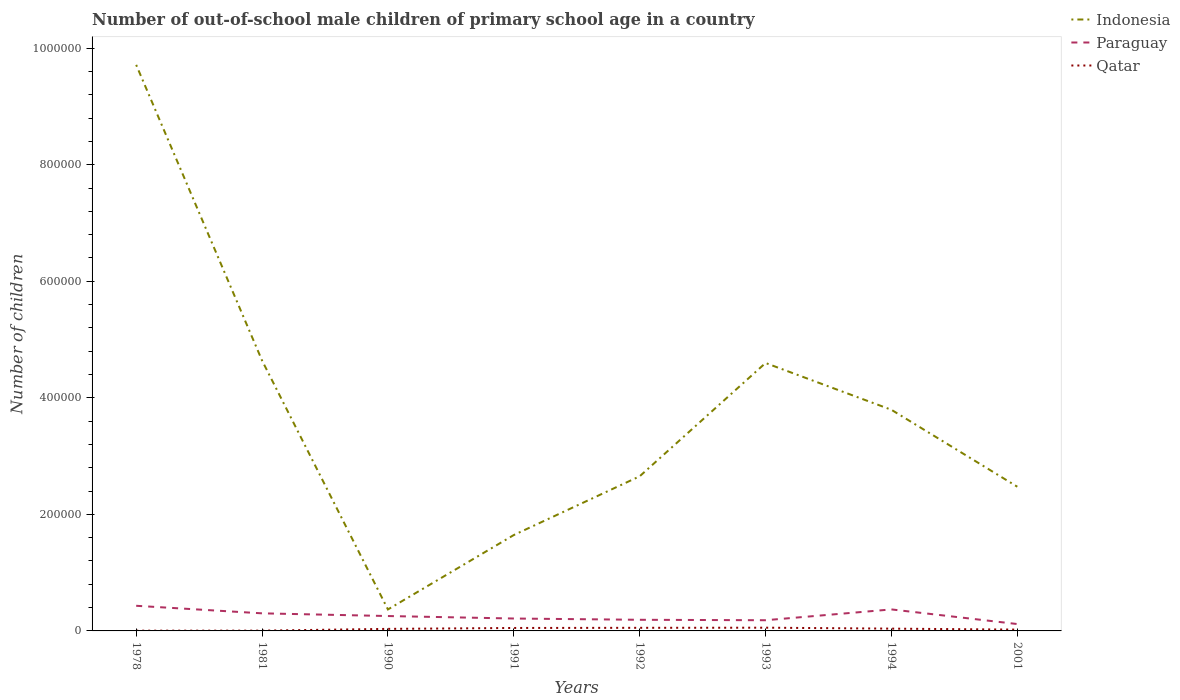Does the line corresponding to Qatar intersect with the line corresponding to Paraguay?
Give a very brief answer. No. Is the number of lines equal to the number of legend labels?
Offer a terse response. Yes. Across all years, what is the maximum number of out-of-school male children in Qatar?
Keep it short and to the point. 430. In which year was the number of out-of-school male children in Qatar maximum?
Give a very brief answer. 1978. What is the total number of out-of-school male children in Qatar in the graph?
Your answer should be compact. 1407. What is the difference between the highest and the second highest number of out-of-school male children in Indonesia?
Offer a terse response. 9.34e+05. How many years are there in the graph?
Keep it short and to the point. 8. What is the difference between two consecutive major ticks on the Y-axis?
Provide a succinct answer. 2.00e+05. Does the graph contain any zero values?
Give a very brief answer. No. Does the graph contain grids?
Ensure brevity in your answer.  No. What is the title of the graph?
Make the answer very short. Number of out-of-school male children of primary school age in a country. What is the label or title of the Y-axis?
Ensure brevity in your answer.  Number of children. What is the Number of children of Indonesia in 1978?
Your answer should be compact. 9.71e+05. What is the Number of children of Paraguay in 1978?
Offer a very short reply. 4.31e+04. What is the Number of children of Qatar in 1978?
Offer a very short reply. 430. What is the Number of children in Indonesia in 1981?
Provide a short and direct response. 4.64e+05. What is the Number of children of Paraguay in 1981?
Your response must be concise. 3.02e+04. What is the Number of children in Qatar in 1981?
Make the answer very short. 488. What is the Number of children in Indonesia in 1990?
Your answer should be very brief. 3.68e+04. What is the Number of children of Paraguay in 1990?
Offer a terse response. 2.56e+04. What is the Number of children in Qatar in 1990?
Offer a terse response. 3512. What is the Number of children in Indonesia in 1991?
Ensure brevity in your answer.  1.65e+05. What is the Number of children in Paraguay in 1991?
Offer a very short reply. 2.13e+04. What is the Number of children of Qatar in 1991?
Provide a short and direct response. 5064. What is the Number of children of Indonesia in 1992?
Offer a terse response. 2.65e+05. What is the Number of children of Paraguay in 1992?
Offer a very short reply. 1.91e+04. What is the Number of children of Qatar in 1992?
Offer a very short reply. 5330. What is the Number of children of Indonesia in 1993?
Offer a very short reply. 4.60e+05. What is the Number of children in Paraguay in 1993?
Offer a terse response. 1.84e+04. What is the Number of children of Qatar in 1993?
Provide a succinct answer. 5541. What is the Number of children in Indonesia in 1994?
Offer a very short reply. 3.79e+05. What is the Number of children in Paraguay in 1994?
Make the answer very short. 3.69e+04. What is the Number of children of Qatar in 1994?
Your answer should be compact. 3923. What is the Number of children of Indonesia in 2001?
Make the answer very short. 2.47e+05. What is the Number of children in Paraguay in 2001?
Your response must be concise. 1.18e+04. What is the Number of children of Qatar in 2001?
Make the answer very short. 2252. Across all years, what is the maximum Number of children in Indonesia?
Give a very brief answer. 9.71e+05. Across all years, what is the maximum Number of children of Paraguay?
Ensure brevity in your answer.  4.31e+04. Across all years, what is the maximum Number of children in Qatar?
Offer a very short reply. 5541. Across all years, what is the minimum Number of children in Indonesia?
Keep it short and to the point. 3.68e+04. Across all years, what is the minimum Number of children in Paraguay?
Give a very brief answer. 1.18e+04. Across all years, what is the minimum Number of children in Qatar?
Give a very brief answer. 430. What is the total Number of children of Indonesia in the graph?
Your response must be concise. 2.99e+06. What is the total Number of children in Paraguay in the graph?
Your answer should be compact. 2.06e+05. What is the total Number of children in Qatar in the graph?
Provide a short and direct response. 2.65e+04. What is the difference between the Number of children of Indonesia in 1978 and that in 1981?
Ensure brevity in your answer.  5.07e+05. What is the difference between the Number of children in Paraguay in 1978 and that in 1981?
Ensure brevity in your answer.  1.30e+04. What is the difference between the Number of children in Qatar in 1978 and that in 1981?
Keep it short and to the point. -58. What is the difference between the Number of children in Indonesia in 1978 and that in 1990?
Your answer should be very brief. 9.34e+05. What is the difference between the Number of children of Paraguay in 1978 and that in 1990?
Your answer should be compact. 1.76e+04. What is the difference between the Number of children in Qatar in 1978 and that in 1990?
Your answer should be very brief. -3082. What is the difference between the Number of children of Indonesia in 1978 and that in 1991?
Your answer should be very brief. 8.07e+05. What is the difference between the Number of children of Paraguay in 1978 and that in 1991?
Your answer should be compact. 2.19e+04. What is the difference between the Number of children of Qatar in 1978 and that in 1991?
Your answer should be compact. -4634. What is the difference between the Number of children in Indonesia in 1978 and that in 1992?
Offer a very short reply. 7.06e+05. What is the difference between the Number of children in Paraguay in 1978 and that in 1992?
Provide a succinct answer. 2.40e+04. What is the difference between the Number of children in Qatar in 1978 and that in 1992?
Keep it short and to the point. -4900. What is the difference between the Number of children of Indonesia in 1978 and that in 1993?
Provide a short and direct response. 5.12e+05. What is the difference between the Number of children of Paraguay in 1978 and that in 1993?
Offer a terse response. 2.48e+04. What is the difference between the Number of children in Qatar in 1978 and that in 1993?
Keep it short and to the point. -5111. What is the difference between the Number of children of Indonesia in 1978 and that in 1994?
Offer a terse response. 5.92e+05. What is the difference between the Number of children in Paraguay in 1978 and that in 1994?
Your response must be concise. 6243. What is the difference between the Number of children of Qatar in 1978 and that in 1994?
Provide a short and direct response. -3493. What is the difference between the Number of children in Indonesia in 1978 and that in 2001?
Provide a short and direct response. 7.24e+05. What is the difference between the Number of children in Paraguay in 1978 and that in 2001?
Your response must be concise. 3.13e+04. What is the difference between the Number of children in Qatar in 1978 and that in 2001?
Make the answer very short. -1822. What is the difference between the Number of children of Indonesia in 1981 and that in 1990?
Provide a succinct answer. 4.27e+05. What is the difference between the Number of children in Paraguay in 1981 and that in 1990?
Keep it short and to the point. 4638. What is the difference between the Number of children of Qatar in 1981 and that in 1990?
Your response must be concise. -3024. What is the difference between the Number of children of Indonesia in 1981 and that in 1991?
Offer a terse response. 2.99e+05. What is the difference between the Number of children in Paraguay in 1981 and that in 1991?
Your answer should be very brief. 8909. What is the difference between the Number of children of Qatar in 1981 and that in 1991?
Your response must be concise. -4576. What is the difference between the Number of children of Indonesia in 1981 and that in 1992?
Make the answer very short. 1.99e+05. What is the difference between the Number of children of Paraguay in 1981 and that in 1992?
Your response must be concise. 1.11e+04. What is the difference between the Number of children of Qatar in 1981 and that in 1992?
Ensure brevity in your answer.  -4842. What is the difference between the Number of children in Indonesia in 1981 and that in 1993?
Give a very brief answer. 4240. What is the difference between the Number of children in Paraguay in 1981 and that in 1993?
Ensure brevity in your answer.  1.18e+04. What is the difference between the Number of children in Qatar in 1981 and that in 1993?
Offer a very short reply. -5053. What is the difference between the Number of children in Indonesia in 1981 and that in 1994?
Ensure brevity in your answer.  8.46e+04. What is the difference between the Number of children in Paraguay in 1981 and that in 1994?
Offer a very short reply. -6714. What is the difference between the Number of children of Qatar in 1981 and that in 1994?
Offer a very short reply. -3435. What is the difference between the Number of children in Indonesia in 1981 and that in 2001?
Provide a succinct answer. 2.17e+05. What is the difference between the Number of children in Paraguay in 1981 and that in 2001?
Your answer should be compact. 1.84e+04. What is the difference between the Number of children of Qatar in 1981 and that in 2001?
Your answer should be compact. -1764. What is the difference between the Number of children of Indonesia in 1990 and that in 1991?
Ensure brevity in your answer.  -1.28e+05. What is the difference between the Number of children in Paraguay in 1990 and that in 1991?
Your response must be concise. 4271. What is the difference between the Number of children of Qatar in 1990 and that in 1991?
Ensure brevity in your answer.  -1552. What is the difference between the Number of children of Indonesia in 1990 and that in 1992?
Your answer should be very brief. -2.28e+05. What is the difference between the Number of children in Paraguay in 1990 and that in 1992?
Ensure brevity in your answer.  6445. What is the difference between the Number of children in Qatar in 1990 and that in 1992?
Offer a terse response. -1818. What is the difference between the Number of children in Indonesia in 1990 and that in 1993?
Make the answer very short. -4.23e+05. What is the difference between the Number of children of Paraguay in 1990 and that in 1993?
Give a very brief answer. 7200. What is the difference between the Number of children of Qatar in 1990 and that in 1993?
Provide a succinct answer. -2029. What is the difference between the Number of children of Indonesia in 1990 and that in 1994?
Your response must be concise. -3.43e+05. What is the difference between the Number of children in Paraguay in 1990 and that in 1994?
Offer a very short reply. -1.14e+04. What is the difference between the Number of children of Qatar in 1990 and that in 1994?
Provide a succinct answer. -411. What is the difference between the Number of children in Indonesia in 1990 and that in 2001?
Make the answer very short. -2.11e+05. What is the difference between the Number of children of Paraguay in 1990 and that in 2001?
Your response must be concise. 1.37e+04. What is the difference between the Number of children of Qatar in 1990 and that in 2001?
Offer a terse response. 1260. What is the difference between the Number of children in Indonesia in 1991 and that in 1992?
Keep it short and to the point. -1.01e+05. What is the difference between the Number of children in Paraguay in 1991 and that in 1992?
Your answer should be very brief. 2174. What is the difference between the Number of children of Qatar in 1991 and that in 1992?
Your answer should be compact. -266. What is the difference between the Number of children in Indonesia in 1991 and that in 1993?
Ensure brevity in your answer.  -2.95e+05. What is the difference between the Number of children of Paraguay in 1991 and that in 1993?
Your answer should be compact. 2929. What is the difference between the Number of children of Qatar in 1991 and that in 1993?
Make the answer very short. -477. What is the difference between the Number of children of Indonesia in 1991 and that in 1994?
Offer a very short reply. -2.15e+05. What is the difference between the Number of children of Paraguay in 1991 and that in 1994?
Provide a succinct answer. -1.56e+04. What is the difference between the Number of children of Qatar in 1991 and that in 1994?
Your answer should be compact. 1141. What is the difference between the Number of children of Indonesia in 1991 and that in 2001?
Provide a succinct answer. -8.29e+04. What is the difference between the Number of children of Paraguay in 1991 and that in 2001?
Provide a succinct answer. 9477. What is the difference between the Number of children in Qatar in 1991 and that in 2001?
Ensure brevity in your answer.  2812. What is the difference between the Number of children of Indonesia in 1992 and that in 1993?
Offer a very short reply. -1.94e+05. What is the difference between the Number of children of Paraguay in 1992 and that in 1993?
Provide a succinct answer. 755. What is the difference between the Number of children of Qatar in 1992 and that in 1993?
Offer a very short reply. -211. What is the difference between the Number of children in Indonesia in 1992 and that in 1994?
Your answer should be compact. -1.14e+05. What is the difference between the Number of children of Paraguay in 1992 and that in 1994?
Give a very brief answer. -1.78e+04. What is the difference between the Number of children of Qatar in 1992 and that in 1994?
Offer a terse response. 1407. What is the difference between the Number of children of Indonesia in 1992 and that in 2001?
Keep it short and to the point. 1.79e+04. What is the difference between the Number of children of Paraguay in 1992 and that in 2001?
Your response must be concise. 7303. What is the difference between the Number of children of Qatar in 1992 and that in 2001?
Your answer should be very brief. 3078. What is the difference between the Number of children in Indonesia in 1993 and that in 1994?
Your response must be concise. 8.03e+04. What is the difference between the Number of children of Paraguay in 1993 and that in 1994?
Your answer should be very brief. -1.86e+04. What is the difference between the Number of children in Qatar in 1993 and that in 1994?
Your response must be concise. 1618. What is the difference between the Number of children of Indonesia in 1993 and that in 2001?
Your response must be concise. 2.12e+05. What is the difference between the Number of children in Paraguay in 1993 and that in 2001?
Your answer should be very brief. 6548. What is the difference between the Number of children in Qatar in 1993 and that in 2001?
Your answer should be very brief. 3289. What is the difference between the Number of children of Indonesia in 1994 and that in 2001?
Offer a terse response. 1.32e+05. What is the difference between the Number of children of Paraguay in 1994 and that in 2001?
Give a very brief answer. 2.51e+04. What is the difference between the Number of children of Qatar in 1994 and that in 2001?
Your answer should be very brief. 1671. What is the difference between the Number of children in Indonesia in 1978 and the Number of children in Paraguay in 1981?
Your answer should be compact. 9.41e+05. What is the difference between the Number of children of Indonesia in 1978 and the Number of children of Qatar in 1981?
Your answer should be very brief. 9.71e+05. What is the difference between the Number of children of Paraguay in 1978 and the Number of children of Qatar in 1981?
Provide a short and direct response. 4.27e+04. What is the difference between the Number of children in Indonesia in 1978 and the Number of children in Paraguay in 1990?
Ensure brevity in your answer.  9.46e+05. What is the difference between the Number of children in Indonesia in 1978 and the Number of children in Qatar in 1990?
Make the answer very short. 9.68e+05. What is the difference between the Number of children of Paraguay in 1978 and the Number of children of Qatar in 1990?
Your answer should be very brief. 3.96e+04. What is the difference between the Number of children of Indonesia in 1978 and the Number of children of Paraguay in 1991?
Provide a succinct answer. 9.50e+05. What is the difference between the Number of children of Indonesia in 1978 and the Number of children of Qatar in 1991?
Offer a terse response. 9.66e+05. What is the difference between the Number of children of Paraguay in 1978 and the Number of children of Qatar in 1991?
Provide a short and direct response. 3.81e+04. What is the difference between the Number of children in Indonesia in 1978 and the Number of children in Paraguay in 1992?
Make the answer very short. 9.52e+05. What is the difference between the Number of children of Indonesia in 1978 and the Number of children of Qatar in 1992?
Make the answer very short. 9.66e+05. What is the difference between the Number of children in Paraguay in 1978 and the Number of children in Qatar in 1992?
Your answer should be very brief. 3.78e+04. What is the difference between the Number of children of Indonesia in 1978 and the Number of children of Paraguay in 1993?
Provide a short and direct response. 9.53e+05. What is the difference between the Number of children in Indonesia in 1978 and the Number of children in Qatar in 1993?
Provide a succinct answer. 9.66e+05. What is the difference between the Number of children of Paraguay in 1978 and the Number of children of Qatar in 1993?
Keep it short and to the point. 3.76e+04. What is the difference between the Number of children in Indonesia in 1978 and the Number of children in Paraguay in 1994?
Give a very brief answer. 9.34e+05. What is the difference between the Number of children in Indonesia in 1978 and the Number of children in Qatar in 1994?
Give a very brief answer. 9.67e+05. What is the difference between the Number of children of Paraguay in 1978 and the Number of children of Qatar in 1994?
Make the answer very short. 3.92e+04. What is the difference between the Number of children of Indonesia in 1978 and the Number of children of Paraguay in 2001?
Give a very brief answer. 9.60e+05. What is the difference between the Number of children in Indonesia in 1978 and the Number of children in Qatar in 2001?
Keep it short and to the point. 9.69e+05. What is the difference between the Number of children of Paraguay in 1978 and the Number of children of Qatar in 2001?
Your answer should be compact. 4.09e+04. What is the difference between the Number of children in Indonesia in 1981 and the Number of children in Paraguay in 1990?
Ensure brevity in your answer.  4.38e+05. What is the difference between the Number of children of Indonesia in 1981 and the Number of children of Qatar in 1990?
Your answer should be compact. 4.60e+05. What is the difference between the Number of children in Paraguay in 1981 and the Number of children in Qatar in 1990?
Your answer should be very brief. 2.67e+04. What is the difference between the Number of children in Indonesia in 1981 and the Number of children in Paraguay in 1991?
Provide a short and direct response. 4.43e+05. What is the difference between the Number of children in Indonesia in 1981 and the Number of children in Qatar in 1991?
Your answer should be very brief. 4.59e+05. What is the difference between the Number of children of Paraguay in 1981 and the Number of children of Qatar in 1991?
Offer a terse response. 2.51e+04. What is the difference between the Number of children of Indonesia in 1981 and the Number of children of Paraguay in 1992?
Your response must be concise. 4.45e+05. What is the difference between the Number of children of Indonesia in 1981 and the Number of children of Qatar in 1992?
Provide a short and direct response. 4.59e+05. What is the difference between the Number of children in Paraguay in 1981 and the Number of children in Qatar in 1992?
Offer a very short reply. 2.49e+04. What is the difference between the Number of children of Indonesia in 1981 and the Number of children of Paraguay in 1993?
Give a very brief answer. 4.46e+05. What is the difference between the Number of children in Indonesia in 1981 and the Number of children in Qatar in 1993?
Offer a very short reply. 4.58e+05. What is the difference between the Number of children of Paraguay in 1981 and the Number of children of Qatar in 1993?
Provide a short and direct response. 2.46e+04. What is the difference between the Number of children of Indonesia in 1981 and the Number of children of Paraguay in 1994?
Provide a succinct answer. 4.27e+05. What is the difference between the Number of children in Indonesia in 1981 and the Number of children in Qatar in 1994?
Your answer should be compact. 4.60e+05. What is the difference between the Number of children in Paraguay in 1981 and the Number of children in Qatar in 1994?
Give a very brief answer. 2.63e+04. What is the difference between the Number of children in Indonesia in 1981 and the Number of children in Paraguay in 2001?
Offer a terse response. 4.52e+05. What is the difference between the Number of children in Indonesia in 1981 and the Number of children in Qatar in 2001?
Offer a terse response. 4.62e+05. What is the difference between the Number of children of Paraguay in 1981 and the Number of children of Qatar in 2001?
Make the answer very short. 2.79e+04. What is the difference between the Number of children of Indonesia in 1990 and the Number of children of Paraguay in 1991?
Offer a very short reply. 1.56e+04. What is the difference between the Number of children of Indonesia in 1990 and the Number of children of Qatar in 1991?
Ensure brevity in your answer.  3.18e+04. What is the difference between the Number of children in Paraguay in 1990 and the Number of children in Qatar in 1991?
Offer a very short reply. 2.05e+04. What is the difference between the Number of children in Indonesia in 1990 and the Number of children in Paraguay in 1992?
Ensure brevity in your answer.  1.77e+04. What is the difference between the Number of children in Indonesia in 1990 and the Number of children in Qatar in 1992?
Your answer should be compact. 3.15e+04. What is the difference between the Number of children in Paraguay in 1990 and the Number of children in Qatar in 1992?
Keep it short and to the point. 2.02e+04. What is the difference between the Number of children of Indonesia in 1990 and the Number of children of Paraguay in 1993?
Your answer should be very brief. 1.85e+04. What is the difference between the Number of children in Indonesia in 1990 and the Number of children in Qatar in 1993?
Provide a succinct answer. 3.13e+04. What is the difference between the Number of children in Paraguay in 1990 and the Number of children in Qatar in 1993?
Offer a terse response. 2.00e+04. What is the difference between the Number of children in Indonesia in 1990 and the Number of children in Paraguay in 1994?
Your answer should be compact. -53. What is the difference between the Number of children of Indonesia in 1990 and the Number of children of Qatar in 1994?
Ensure brevity in your answer.  3.29e+04. What is the difference between the Number of children in Paraguay in 1990 and the Number of children in Qatar in 1994?
Your response must be concise. 2.16e+04. What is the difference between the Number of children of Indonesia in 1990 and the Number of children of Paraguay in 2001?
Your answer should be very brief. 2.50e+04. What is the difference between the Number of children of Indonesia in 1990 and the Number of children of Qatar in 2001?
Your answer should be very brief. 3.46e+04. What is the difference between the Number of children in Paraguay in 1990 and the Number of children in Qatar in 2001?
Provide a succinct answer. 2.33e+04. What is the difference between the Number of children in Indonesia in 1991 and the Number of children in Paraguay in 1992?
Your answer should be very brief. 1.45e+05. What is the difference between the Number of children of Indonesia in 1991 and the Number of children of Qatar in 1992?
Ensure brevity in your answer.  1.59e+05. What is the difference between the Number of children in Paraguay in 1991 and the Number of children in Qatar in 1992?
Provide a succinct answer. 1.60e+04. What is the difference between the Number of children in Indonesia in 1991 and the Number of children in Paraguay in 1993?
Make the answer very short. 1.46e+05. What is the difference between the Number of children of Indonesia in 1991 and the Number of children of Qatar in 1993?
Your response must be concise. 1.59e+05. What is the difference between the Number of children of Paraguay in 1991 and the Number of children of Qatar in 1993?
Provide a succinct answer. 1.57e+04. What is the difference between the Number of children of Indonesia in 1991 and the Number of children of Paraguay in 1994?
Offer a terse response. 1.28e+05. What is the difference between the Number of children in Indonesia in 1991 and the Number of children in Qatar in 1994?
Ensure brevity in your answer.  1.61e+05. What is the difference between the Number of children of Paraguay in 1991 and the Number of children of Qatar in 1994?
Offer a very short reply. 1.74e+04. What is the difference between the Number of children of Indonesia in 1991 and the Number of children of Paraguay in 2001?
Make the answer very short. 1.53e+05. What is the difference between the Number of children of Indonesia in 1991 and the Number of children of Qatar in 2001?
Provide a succinct answer. 1.62e+05. What is the difference between the Number of children of Paraguay in 1991 and the Number of children of Qatar in 2001?
Ensure brevity in your answer.  1.90e+04. What is the difference between the Number of children of Indonesia in 1992 and the Number of children of Paraguay in 1993?
Provide a short and direct response. 2.47e+05. What is the difference between the Number of children of Indonesia in 1992 and the Number of children of Qatar in 1993?
Provide a short and direct response. 2.60e+05. What is the difference between the Number of children in Paraguay in 1992 and the Number of children in Qatar in 1993?
Your answer should be compact. 1.36e+04. What is the difference between the Number of children in Indonesia in 1992 and the Number of children in Paraguay in 1994?
Your response must be concise. 2.28e+05. What is the difference between the Number of children in Indonesia in 1992 and the Number of children in Qatar in 1994?
Offer a very short reply. 2.61e+05. What is the difference between the Number of children in Paraguay in 1992 and the Number of children in Qatar in 1994?
Make the answer very short. 1.52e+04. What is the difference between the Number of children of Indonesia in 1992 and the Number of children of Paraguay in 2001?
Offer a very short reply. 2.54e+05. What is the difference between the Number of children in Indonesia in 1992 and the Number of children in Qatar in 2001?
Ensure brevity in your answer.  2.63e+05. What is the difference between the Number of children in Paraguay in 1992 and the Number of children in Qatar in 2001?
Make the answer very short. 1.69e+04. What is the difference between the Number of children of Indonesia in 1993 and the Number of children of Paraguay in 1994?
Make the answer very short. 4.23e+05. What is the difference between the Number of children of Indonesia in 1993 and the Number of children of Qatar in 1994?
Keep it short and to the point. 4.56e+05. What is the difference between the Number of children in Paraguay in 1993 and the Number of children in Qatar in 1994?
Your answer should be compact. 1.44e+04. What is the difference between the Number of children in Indonesia in 1993 and the Number of children in Paraguay in 2001?
Give a very brief answer. 4.48e+05. What is the difference between the Number of children of Indonesia in 1993 and the Number of children of Qatar in 2001?
Provide a short and direct response. 4.58e+05. What is the difference between the Number of children in Paraguay in 1993 and the Number of children in Qatar in 2001?
Your answer should be very brief. 1.61e+04. What is the difference between the Number of children of Indonesia in 1994 and the Number of children of Paraguay in 2001?
Your answer should be very brief. 3.68e+05. What is the difference between the Number of children of Indonesia in 1994 and the Number of children of Qatar in 2001?
Ensure brevity in your answer.  3.77e+05. What is the difference between the Number of children in Paraguay in 1994 and the Number of children in Qatar in 2001?
Make the answer very short. 3.47e+04. What is the average Number of children of Indonesia per year?
Keep it short and to the point. 3.74e+05. What is the average Number of children of Paraguay per year?
Offer a very short reply. 2.58e+04. What is the average Number of children in Qatar per year?
Offer a terse response. 3317.5. In the year 1978, what is the difference between the Number of children in Indonesia and Number of children in Paraguay?
Ensure brevity in your answer.  9.28e+05. In the year 1978, what is the difference between the Number of children of Indonesia and Number of children of Qatar?
Offer a terse response. 9.71e+05. In the year 1978, what is the difference between the Number of children of Paraguay and Number of children of Qatar?
Your answer should be compact. 4.27e+04. In the year 1981, what is the difference between the Number of children in Indonesia and Number of children in Paraguay?
Ensure brevity in your answer.  4.34e+05. In the year 1981, what is the difference between the Number of children of Indonesia and Number of children of Qatar?
Provide a succinct answer. 4.64e+05. In the year 1981, what is the difference between the Number of children of Paraguay and Number of children of Qatar?
Offer a very short reply. 2.97e+04. In the year 1990, what is the difference between the Number of children in Indonesia and Number of children in Paraguay?
Provide a succinct answer. 1.13e+04. In the year 1990, what is the difference between the Number of children in Indonesia and Number of children in Qatar?
Your response must be concise. 3.33e+04. In the year 1990, what is the difference between the Number of children of Paraguay and Number of children of Qatar?
Make the answer very short. 2.20e+04. In the year 1991, what is the difference between the Number of children of Indonesia and Number of children of Paraguay?
Offer a very short reply. 1.43e+05. In the year 1991, what is the difference between the Number of children in Indonesia and Number of children in Qatar?
Provide a short and direct response. 1.59e+05. In the year 1991, what is the difference between the Number of children of Paraguay and Number of children of Qatar?
Give a very brief answer. 1.62e+04. In the year 1992, what is the difference between the Number of children of Indonesia and Number of children of Paraguay?
Offer a terse response. 2.46e+05. In the year 1992, what is the difference between the Number of children in Indonesia and Number of children in Qatar?
Provide a short and direct response. 2.60e+05. In the year 1992, what is the difference between the Number of children in Paraguay and Number of children in Qatar?
Offer a very short reply. 1.38e+04. In the year 1993, what is the difference between the Number of children in Indonesia and Number of children in Paraguay?
Provide a short and direct response. 4.41e+05. In the year 1993, what is the difference between the Number of children in Indonesia and Number of children in Qatar?
Offer a terse response. 4.54e+05. In the year 1993, what is the difference between the Number of children in Paraguay and Number of children in Qatar?
Provide a succinct answer. 1.28e+04. In the year 1994, what is the difference between the Number of children of Indonesia and Number of children of Paraguay?
Provide a succinct answer. 3.43e+05. In the year 1994, what is the difference between the Number of children of Indonesia and Number of children of Qatar?
Provide a succinct answer. 3.76e+05. In the year 1994, what is the difference between the Number of children in Paraguay and Number of children in Qatar?
Offer a very short reply. 3.30e+04. In the year 2001, what is the difference between the Number of children in Indonesia and Number of children in Paraguay?
Offer a terse response. 2.36e+05. In the year 2001, what is the difference between the Number of children of Indonesia and Number of children of Qatar?
Your response must be concise. 2.45e+05. In the year 2001, what is the difference between the Number of children in Paraguay and Number of children in Qatar?
Make the answer very short. 9551. What is the ratio of the Number of children in Indonesia in 1978 to that in 1981?
Offer a terse response. 2.09. What is the ratio of the Number of children in Paraguay in 1978 to that in 1981?
Ensure brevity in your answer.  1.43. What is the ratio of the Number of children in Qatar in 1978 to that in 1981?
Your response must be concise. 0.88. What is the ratio of the Number of children of Indonesia in 1978 to that in 1990?
Your response must be concise. 26.36. What is the ratio of the Number of children in Paraguay in 1978 to that in 1990?
Provide a short and direct response. 1.69. What is the ratio of the Number of children of Qatar in 1978 to that in 1990?
Ensure brevity in your answer.  0.12. What is the ratio of the Number of children in Indonesia in 1978 to that in 1991?
Keep it short and to the point. 5.9. What is the ratio of the Number of children in Paraguay in 1978 to that in 1991?
Offer a terse response. 2.03. What is the ratio of the Number of children of Qatar in 1978 to that in 1991?
Provide a short and direct response. 0.08. What is the ratio of the Number of children of Indonesia in 1978 to that in 1992?
Your response must be concise. 3.66. What is the ratio of the Number of children in Paraguay in 1978 to that in 1992?
Your answer should be very brief. 2.26. What is the ratio of the Number of children in Qatar in 1978 to that in 1992?
Offer a very short reply. 0.08. What is the ratio of the Number of children of Indonesia in 1978 to that in 1993?
Provide a succinct answer. 2.11. What is the ratio of the Number of children of Paraguay in 1978 to that in 1993?
Offer a very short reply. 2.35. What is the ratio of the Number of children of Qatar in 1978 to that in 1993?
Keep it short and to the point. 0.08. What is the ratio of the Number of children of Indonesia in 1978 to that in 1994?
Your answer should be compact. 2.56. What is the ratio of the Number of children in Paraguay in 1978 to that in 1994?
Provide a short and direct response. 1.17. What is the ratio of the Number of children of Qatar in 1978 to that in 1994?
Your response must be concise. 0.11. What is the ratio of the Number of children of Indonesia in 1978 to that in 2001?
Offer a very short reply. 3.93. What is the ratio of the Number of children in Paraguay in 1978 to that in 2001?
Offer a very short reply. 3.66. What is the ratio of the Number of children in Qatar in 1978 to that in 2001?
Offer a terse response. 0.19. What is the ratio of the Number of children in Indonesia in 1981 to that in 1990?
Your response must be concise. 12.59. What is the ratio of the Number of children in Paraguay in 1981 to that in 1990?
Provide a succinct answer. 1.18. What is the ratio of the Number of children in Qatar in 1981 to that in 1990?
Give a very brief answer. 0.14. What is the ratio of the Number of children in Indonesia in 1981 to that in 1991?
Provide a succinct answer. 2.82. What is the ratio of the Number of children of Paraguay in 1981 to that in 1991?
Give a very brief answer. 1.42. What is the ratio of the Number of children of Qatar in 1981 to that in 1991?
Your response must be concise. 0.1. What is the ratio of the Number of children of Indonesia in 1981 to that in 1992?
Ensure brevity in your answer.  1.75. What is the ratio of the Number of children of Paraguay in 1981 to that in 1992?
Offer a terse response. 1.58. What is the ratio of the Number of children of Qatar in 1981 to that in 1992?
Provide a succinct answer. 0.09. What is the ratio of the Number of children in Indonesia in 1981 to that in 1993?
Give a very brief answer. 1.01. What is the ratio of the Number of children of Paraguay in 1981 to that in 1993?
Offer a terse response. 1.65. What is the ratio of the Number of children of Qatar in 1981 to that in 1993?
Ensure brevity in your answer.  0.09. What is the ratio of the Number of children of Indonesia in 1981 to that in 1994?
Give a very brief answer. 1.22. What is the ratio of the Number of children in Paraguay in 1981 to that in 1994?
Your answer should be compact. 0.82. What is the ratio of the Number of children of Qatar in 1981 to that in 1994?
Keep it short and to the point. 0.12. What is the ratio of the Number of children of Indonesia in 1981 to that in 2001?
Give a very brief answer. 1.88. What is the ratio of the Number of children in Paraguay in 1981 to that in 2001?
Keep it short and to the point. 2.56. What is the ratio of the Number of children of Qatar in 1981 to that in 2001?
Your answer should be compact. 0.22. What is the ratio of the Number of children of Indonesia in 1990 to that in 1991?
Keep it short and to the point. 0.22. What is the ratio of the Number of children in Paraguay in 1990 to that in 1991?
Provide a short and direct response. 1.2. What is the ratio of the Number of children in Qatar in 1990 to that in 1991?
Provide a succinct answer. 0.69. What is the ratio of the Number of children of Indonesia in 1990 to that in 1992?
Provide a short and direct response. 0.14. What is the ratio of the Number of children of Paraguay in 1990 to that in 1992?
Your response must be concise. 1.34. What is the ratio of the Number of children in Qatar in 1990 to that in 1992?
Give a very brief answer. 0.66. What is the ratio of the Number of children in Indonesia in 1990 to that in 1993?
Ensure brevity in your answer.  0.08. What is the ratio of the Number of children of Paraguay in 1990 to that in 1993?
Offer a very short reply. 1.39. What is the ratio of the Number of children of Qatar in 1990 to that in 1993?
Offer a very short reply. 0.63. What is the ratio of the Number of children in Indonesia in 1990 to that in 1994?
Your answer should be very brief. 0.1. What is the ratio of the Number of children of Paraguay in 1990 to that in 1994?
Ensure brevity in your answer.  0.69. What is the ratio of the Number of children of Qatar in 1990 to that in 1994?
Provide a short and direct response. 0.9. What is the ratio of the Number of children of Indonesia in 1990 to that in 2001?
Make the answer very short. 0.15. What is the ratio of the Number of children of Paraguay in 1990 to that in 2001?
Your answer should be compact. 2.16. What is the ratio of the Number of children in Qatar in 1990 to that in 2001?
Your answer should be very brief. 1.56. What is the ratio of the Number of children of Indonesia in 1991 to that in 1992?
Offer a terse response. 0.62. What is the ratio of the Number of children of Paraguay in 1991 to that in 1992?
Your response must be concise. 1.11. What is the ratio of the Number of children of Qatar in 1991 to that in 1992?
Offer a terse response. 0.95. What is the ratio of the Number of children of Indonesia in 1991 to that in 1993?
Offer a terse response. 0.36. What is the ratio of the Number of children in Paraguay in 1991 to that in 1993?
Provide a short and direct response. 1.16. What is the ratio of the Number of children of Qatar in 1991 to that in 1993?
Your response must be concise. 0.91. What is the ratio of the Number of children in Indonesia in 1991 to that in 1994?
Give a very brief answer. 0.43. What is the ratio of the Number of children in Paraguay in 1991 to that in 1994?
Keep it short and to the point. 0.58. What is the ratio of the Number of children in Qatar in 1991 to that in 1994?
Ensure brevity in your answer.  1.29. What is the ratio of the Number of children in Indonesia in 1991 to that in 2001?
Ensure brevity in your answer.  0.67. What is the ratio of the Number of children in Paraguay in 1991 to that in 2001?
Offer a very short reply. 1.8. What is the ratio of the Number of children in Qatar in 1991 to that in 2001?
Provide a succinct answer. 2.25. What is the ratio of the Number of children in Indonesia in 1992 to that in 1993?
Your answer should be compact. 0.58. What is the ratio of the Number of children of Paraguay in 1992 to that in 1993?
Your response must be concise. 1.04. What is the ratio of the Number of children in Qatar in 1992 to that in 1993?
Offer a terse response. 0.96. What is the ratio of the Number of children in Indonesia in 1992 to that in 1994?
Offer a very short reply. 0.7. What is the ratio of the Number of children in Paraguay in 1992 to that in 1994?
Provide a succinct answer. 0.52. What is the ratio of the Number of children in Qatar in 1992 to that in 1994?
Provide a succinct answer. 1.36. What is the ratio of the Number of children in Indonesia in 1992 to that in 2001?
Provide a short and direct response. 1.07. What is the ratio of the Number of children of Paraguay in 1992 to that in 2001?
Offer a terse response. 1.62. What is the ratio of the Number of children in Qatar in 1992 to that in 2001?
Ensure brevity in your answer.  2.37. What is the ratio of the Number of children in Indonesia in 1993 to that in 1994?
Offer a terse response. 1.21. What is the ratio of the Number of children of Paraguay in 1993 to that in 1994?
Your answer should be very brief. 0.5. What is the ratio of the Number of children of Qatar in 1993 to that in 1994?
Make the answer very short. 1.41. What is the ratio of the Number of children of Indonesia in 1993 to that in 2001?
Your response must be concise. 1.86. What is the ratio of the Number of children of Paraguay in 1993 to that in 2001?
Your answer should be very brief. 1.55. What is the ratio of the Number of children in Qatar in 1993 to that in 2001?
Make the answer very short. 2.46. What is the ratio of the Number of children of Indonesia in 1994 to that in 2001?
Offer a very short reply. 1.53. What is the ratio of the Number of children in Paraguay in 1994 to that in 2001?
Keep it short and to the point. 3.13. What is the ratio of the Number of children of Qatar in 1994 to that in 2001?
Ensure brevity in your answer.  1.74. What is the difference between the highest and the second highest Number of children in Indonesia?
Offer a terse response. 5.07e+05. What is the difference between the highest and the second highest Number of children in Paraguay?
Your answer should be compact. 6243. What is the difference between the highest and the second highest Number of children in Qatar?
Offer a terse response. 211. What is the difference between the highest and the lowest Number of children in Indonesia?
Offer a terse response. 9.34e+05. What is the difference between the highest and the lowest Number of children in Paraguay?
Ensure brevity in your answer.  3.13e+04. What is the difference between the highest and the lowest Number of children of Qatar?
Ensure brevity in your answer.  5111. 